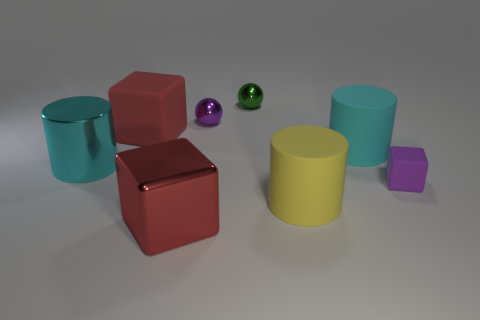Do the big metallic block and the large cylinder in front of the tiny matte cube have the same color?
Provide a succinct answer. No. Are there any other things that have the same material as the tiny green object?
Ensure brevity in your answer.  Yes. What is the shape of the small object in front of the cube that is behind the small purple rubber object?
Offer a very short reply. Cube. The other cylinder that is the same color as the metal cylinder is what size?
Your answer should be compact. Large. Do the big metal thing that is in front of the tiny purple rubber block and the large cyan rubber thing have the same shape?
Your answer should be very brief. No. Is the number of tiny matte objects to the left of the green metal ball greater than the number of purple shiny spheres on the left side of the big red matte cube?
Offer a terse response. No. What number of yellow cylinders are on the right side of the matte cylinder in front of the large cyan metal object?
Your response must be concise. 0. There is another cube that is the same color as the large matte block; what material is it?
Keep it short and to the point. Metal. How many other things are the same color as the large metallic cube?
Keep it short and to the point. 1. What is the color of the big cube that is in front of the cube left of the large red metal object?
Ensure brevity in your answer.  Red. 